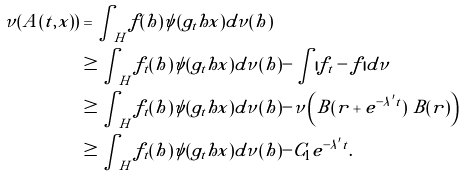<formula> <loc_0><loc_0><loc_500><loc_500>\nu ( A ( t , x ) ) & = \int _ { H } f ( h ) \psi ( g _ { t } h x ) d \nu ( h ) \\ & \geq \int _ { H } f _ { t } ( h ) \psi ( g _ { t } h x ) d \nu ( h ) - \int | f _ { t } - f | d \nu \\ & \geq \int _ { H } f _ { t } ( h ) \psi ( g _ { t } h x ) d \nu ( h ) - \nu \left ( B ( r + e ^ { - \lambda ^ { \prime } t } ) \ B ( r ) \right ) \\ & \geq \int _ { H } f _ { t } ( h ) \psi ( g _ { t } h x ) d \nu ( h ) - C _ { 1 } e ^ { - \lambda ^ { \prime } t } .</formula> 